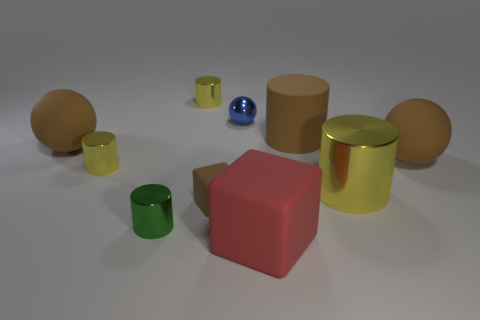There is a large rubber ball that is on the left side of the big metallic thing; what is its color?
Ensure brevity in your answer.  Brown. Are there more brown cylinders that are to the right of the blue metal object than large red rubber objects on the right side of the big yellow cylinder?
Provide a short and direct response. Yes. What size is the yellow shiny object that is left of the shiny cylinder that is in front of the small rubber object that is behind the green metallic thing?
Offer a very short reply. Small. Are there any other metallic spheres that have the same color as the tiny shiny sphere?
Ensure brevity in your answer.  No. How many red rubber objects are there?
Ensure brevity in your answer.  1. What material is the red thing to the right of the big brown object that is left of the big rubber thing in front of the tiny green metal cylinder?
Provide a succinct answer. Rubber. Are there any small blocks made of the same material as the small brown object?
Keep it short and to the point. No. Are the small brown thing and the large block made of the same material?
Provide a succinct answer. Yes. How many spheres are either big red matte objects or tiny metallic things?
Your answer should be compact. 1. There is a large thing that is made of the same material as the tiny blue ball; what color is it?
Your answer should be compact. Yellow. 